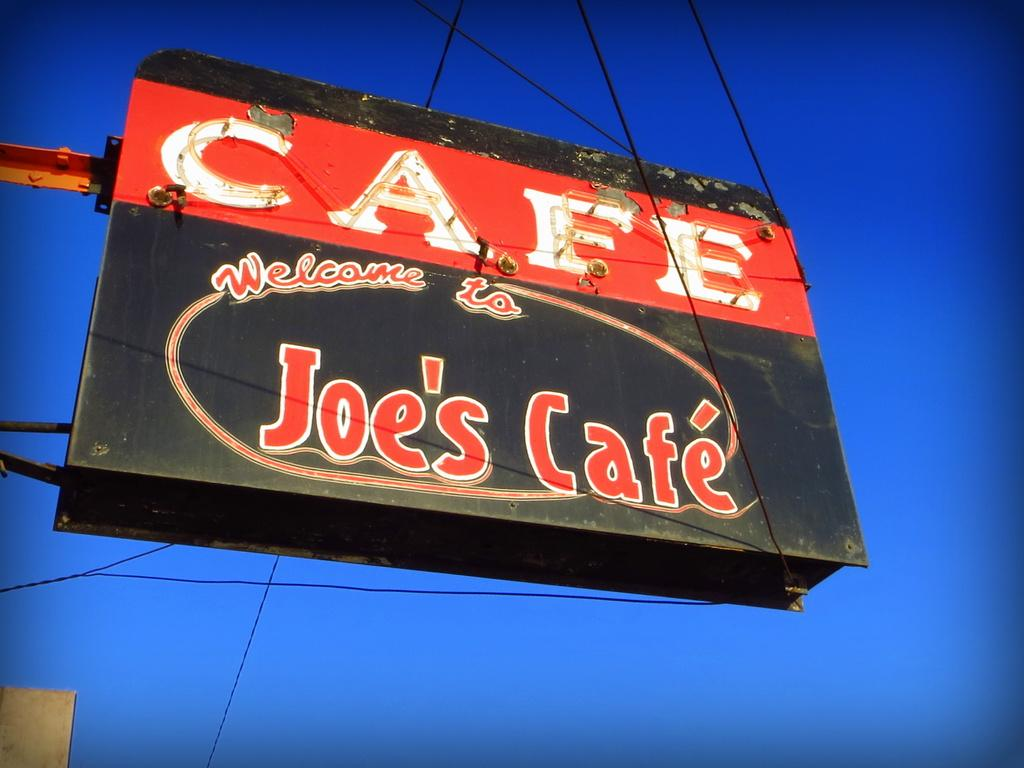<image>
Render a clear and concise summary of the photo. A red and black sign for Joe's Cafe. 